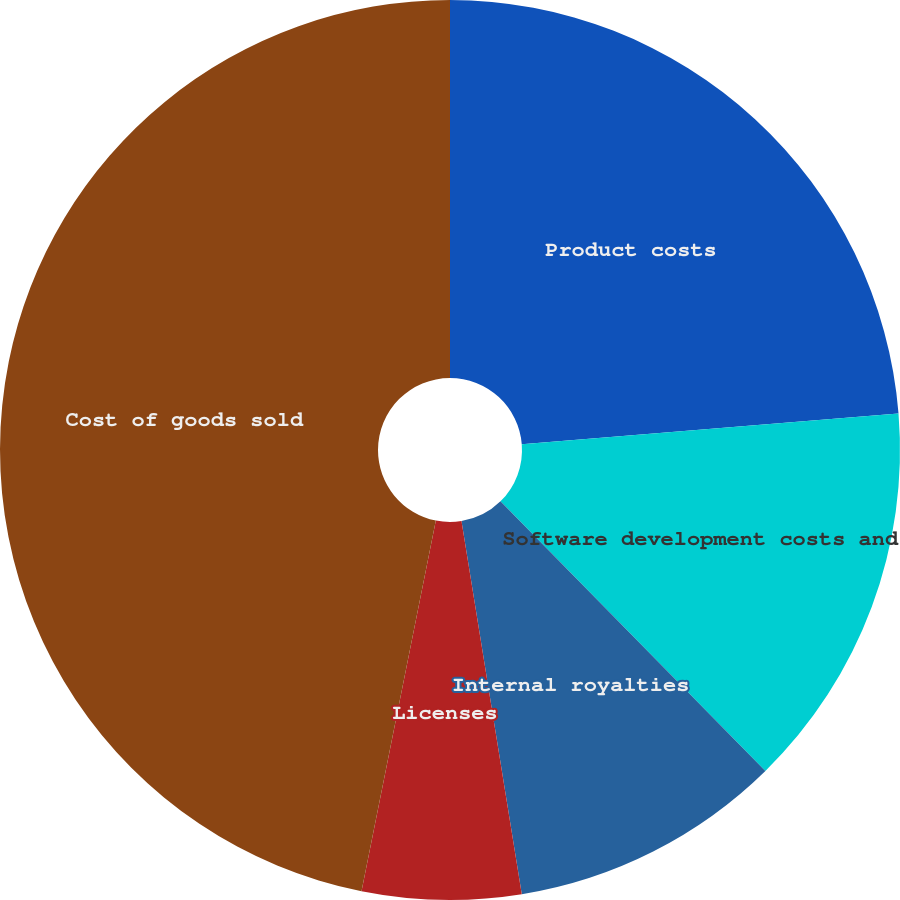Convert chart. <chart><loc_0><loc_0><loc_500><loc_500><pie_chart><fcel>Product costs<fcel>Software development costs and<fcel>Internal royalties<fcel>Licenses<fcel>Cost of goods sold<nl><fcel>23.71%<fcel>13.93%<fcel>9.81%<fcel>5.7%<fcel>46.85%<nl></chart> 